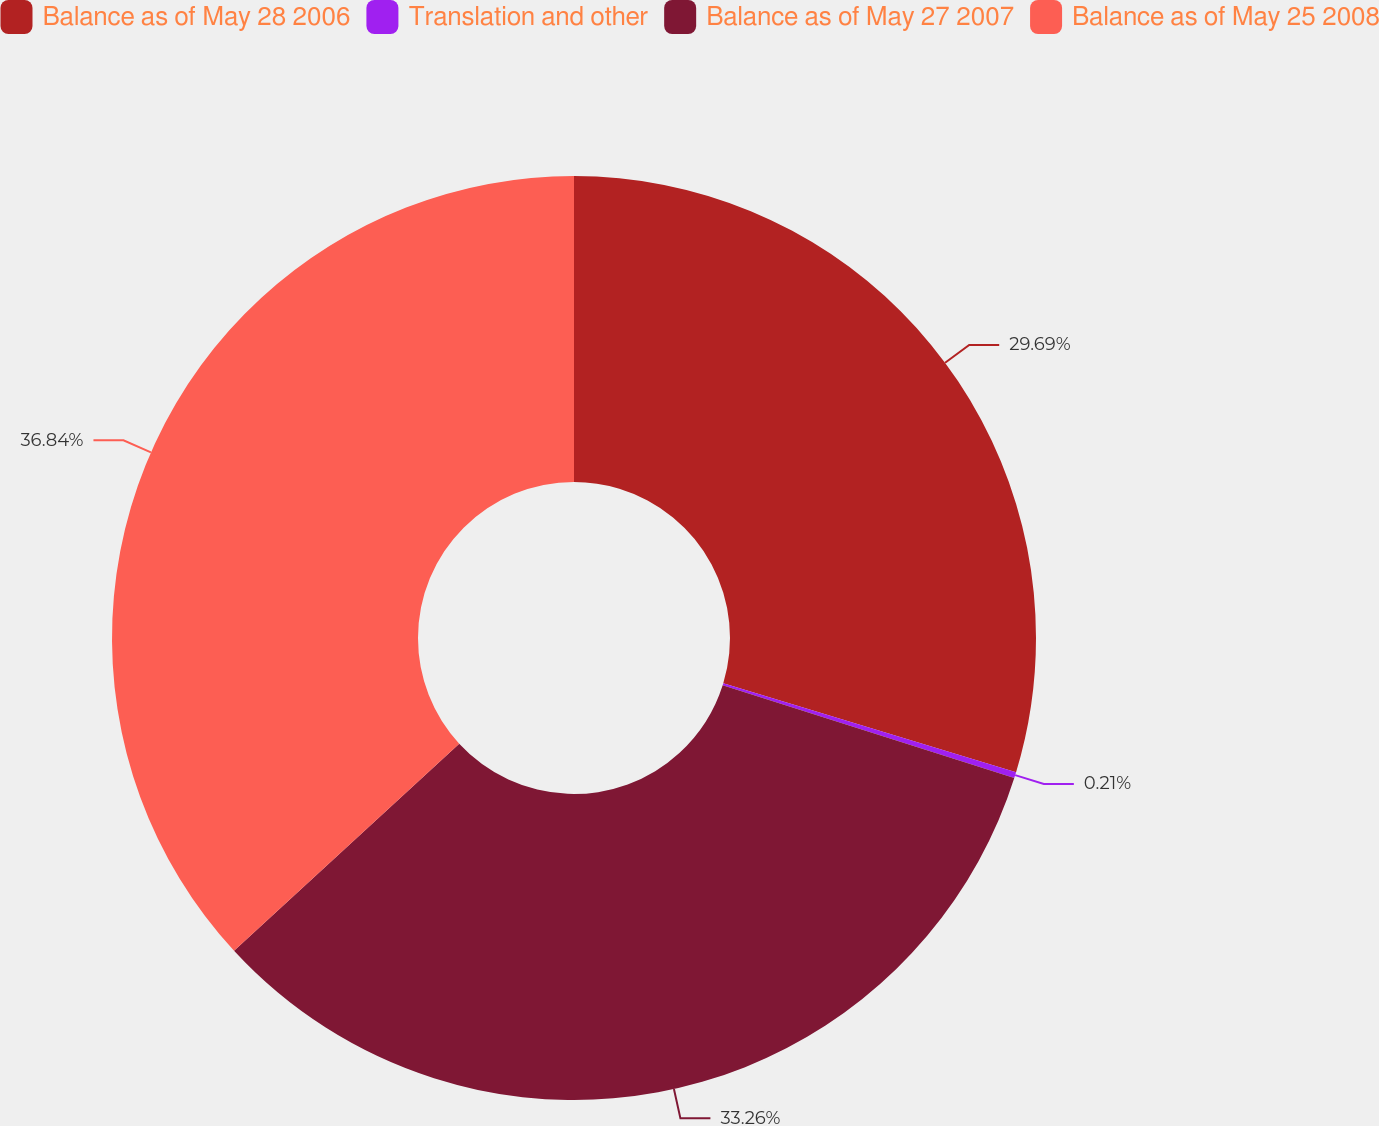<chart> <loc_0><loc_0><loc_500><loc_500><pie_chart><fcel>Balance as of May 28 2006<fcel>Translation and other<fcel>Balance as of May 27 2007<fcel>Balance as of May 25 2008<nl><fcel>29.69%<fcel>0.21%<fcel>33.26%<fcel>36.84%<nl></chart> 